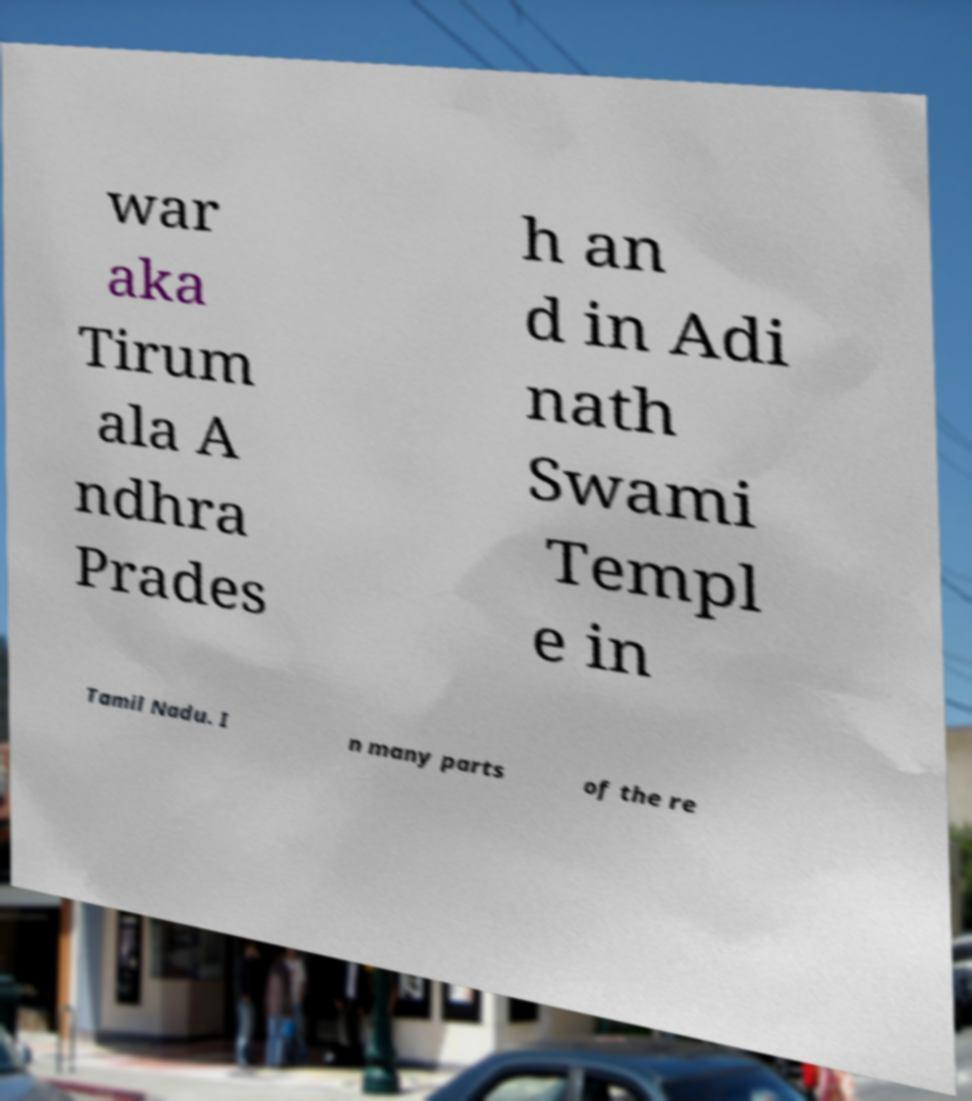What messages or text are displayed in this image? I need them in a readable, typed format. war aka Tirum ala A ndhra Prades h an d in Adi nath Swami Templ e in Tamil Nadu. I n many parts of the re 